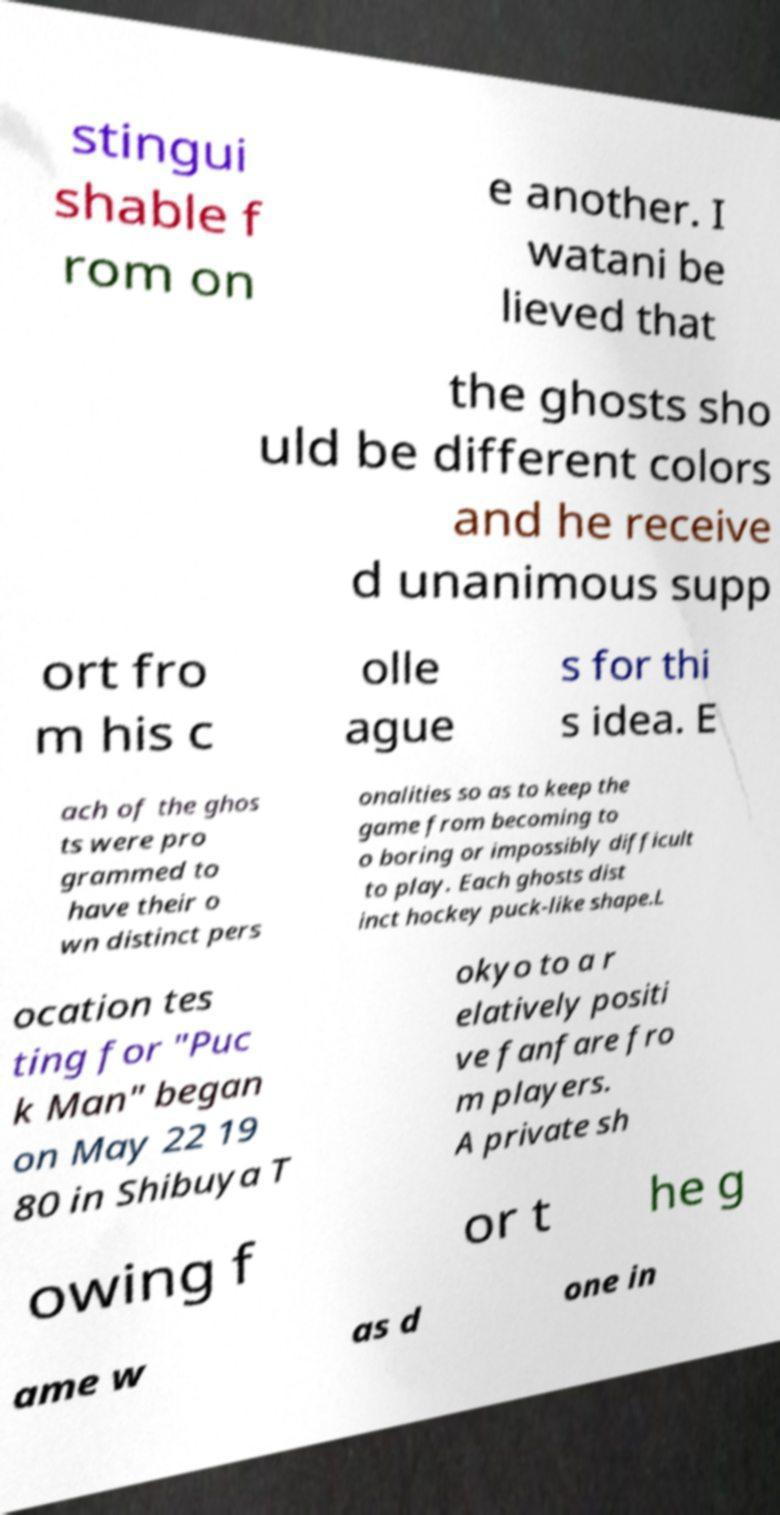Can you accurately transcribe the text from the provided image for me? stingui shable f rom on e another. I watani be lieved that the ghosts sho uld be different colors and he receive d unanimous supp ort fro m his c olle ague s for thi s idea. E ach of the ghos ts were pro grammed to have their o wn distinct pers onalities so as to keep the game from becoming to o boring or impossibly difficult to play. Each ghosts dist inct hockey puck-like shape.L ocation tes ting for "Puc k Man" began on May 22 19 80 in Shibuya T okyo to a r elatively positi ve fanfare fro m players. A private sh owing f or t he g ame w as d one in 